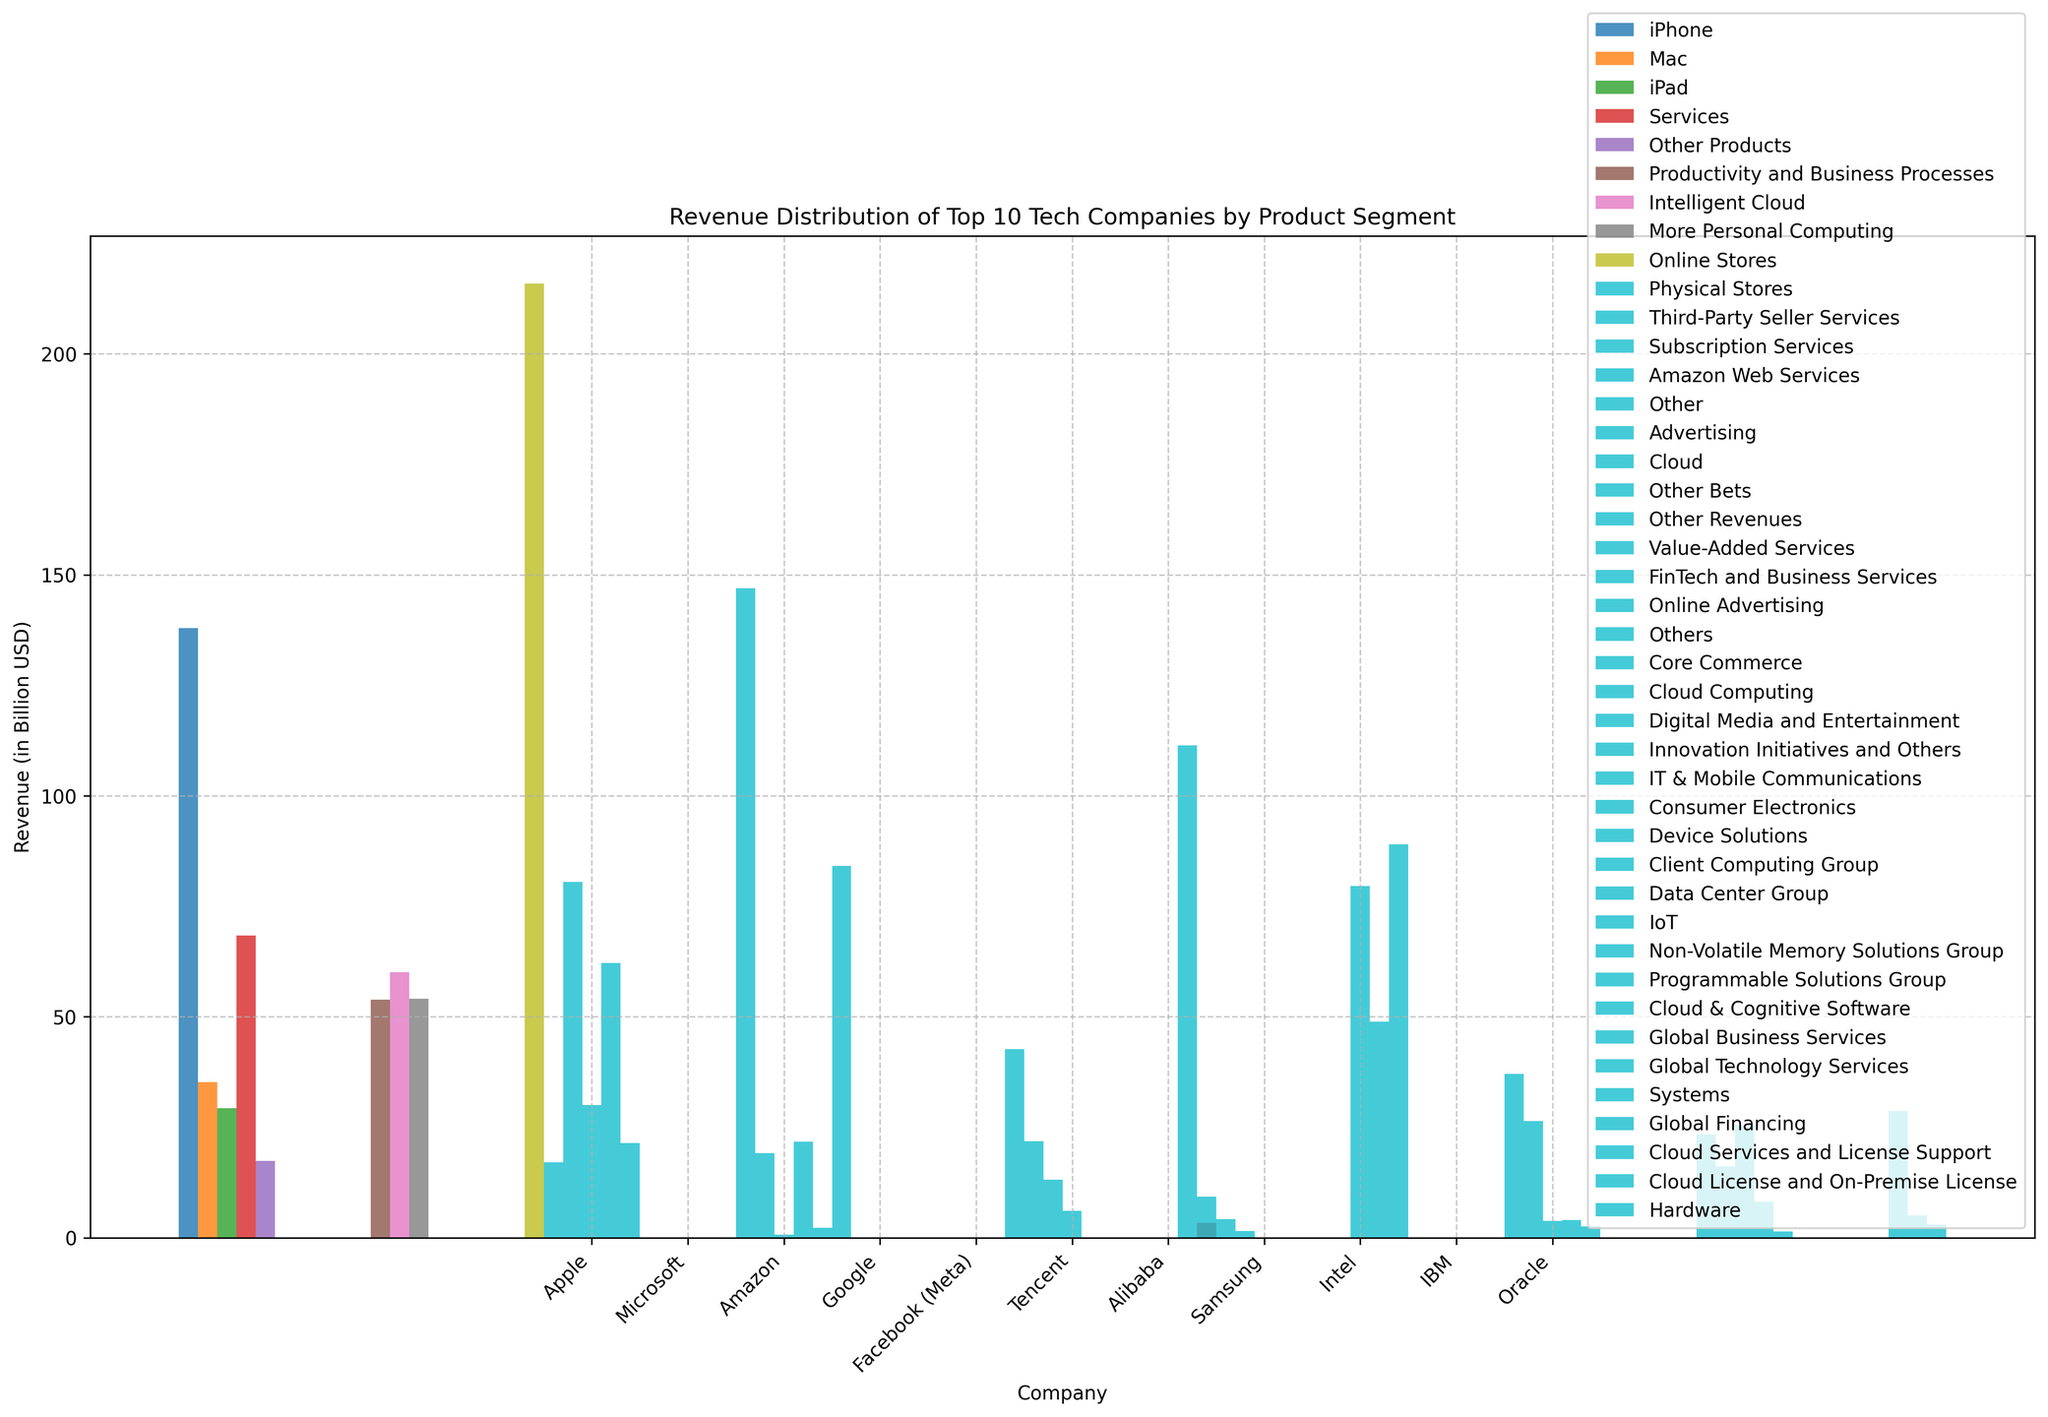Which company has the highest revenue in the 'Cloud' segment? Compare the revenues from the 'Cloud' segment: Microsoft (Intelligent Cloud, $60.1 billion), Amazon (AWS, $62.2 billion), Google (Cloud, $19.2 billion), Alibaba (Cloud Computing, $9.3 billion), IBM (Cloud & Cognitive Software, $23.4 billion), Oracle (Cloud Services and License Support, $28.7 billion). Amazon has the highest revenue in the Cloud segment.
Answer: Amazon What is the difference between the revenues of Amazon's 'Online Stores' and Apple's 'iPhone' product segments? Subtract the revenue of Apple's iPhone from Amazon's Online Stores: 215.9 (Amazon Online Stores) - 138.0 (Apple iPhone).
Answer: 77.9 Which company has the least revenue in any single product segment? Compare all the revenue values from the datasets; Google’s Other Bets has the least revenue of $0.7 billion.
Answer: Google Arrange the product segments of Microsoft in decreasing order of revenue. The product segments of Microsoft are: 60.1 (Intelligent Cloud), 54.1 (More Personal Computing), and 53.9 (Productivity and Business Processes). Arrange in descending order: 60.1 > 54.1 > 53.9.
Answer: Intelligent Cloud > More Personal Computing > Productivity and Business Processes Which product segment generates more revenue: Facebook (Meta) 'Advertising' or Tencent 'Value-Added Services'? Compare the revenue of Facebook (Meta) Advertising ($84.2 billion) and Tencent Value-Added Services ($42.7 billion).
Answer: Facebook (Meta) Advertising How much more revenue does Samsung's 'Device Solutions' generate compared to Intel's 'Data Center Group'? Subtract the revenue of Intel's Data Center Group from Samsung's Device Solutions: 89.0 (Samsung Device Solutions) - 26.4 (Intel Data Center Group).
Answer: 62.6 What color is used for the 'Google Cloud' segment in the plot? Identify the color representing the Google Cloud segment in the plot using visual observation.
Answer: (Assuming color from an unseen plot) What is the average revenue of Alibaba's product segments? Calculate the average by summing the revenues for Alibaba and dividing by the number of segments: (111.4 + 9.3 + 4.2 + 1.5) / 4 = 126.4 / 4.
Answer: 31.6 Which company has a higher total revenue: IBM or Oracle? Sum up the revenues for IBM's segments: 23.4 + 16.2 + 25.5 + 8.2 + 1.4 = 74.7. Do the same for Oracle's segments: 28.7 + 5.1 + 3.0 + 3.4 = 40.2. Compare the two totals, IBM has higher total revenue.
Answer: IBM 